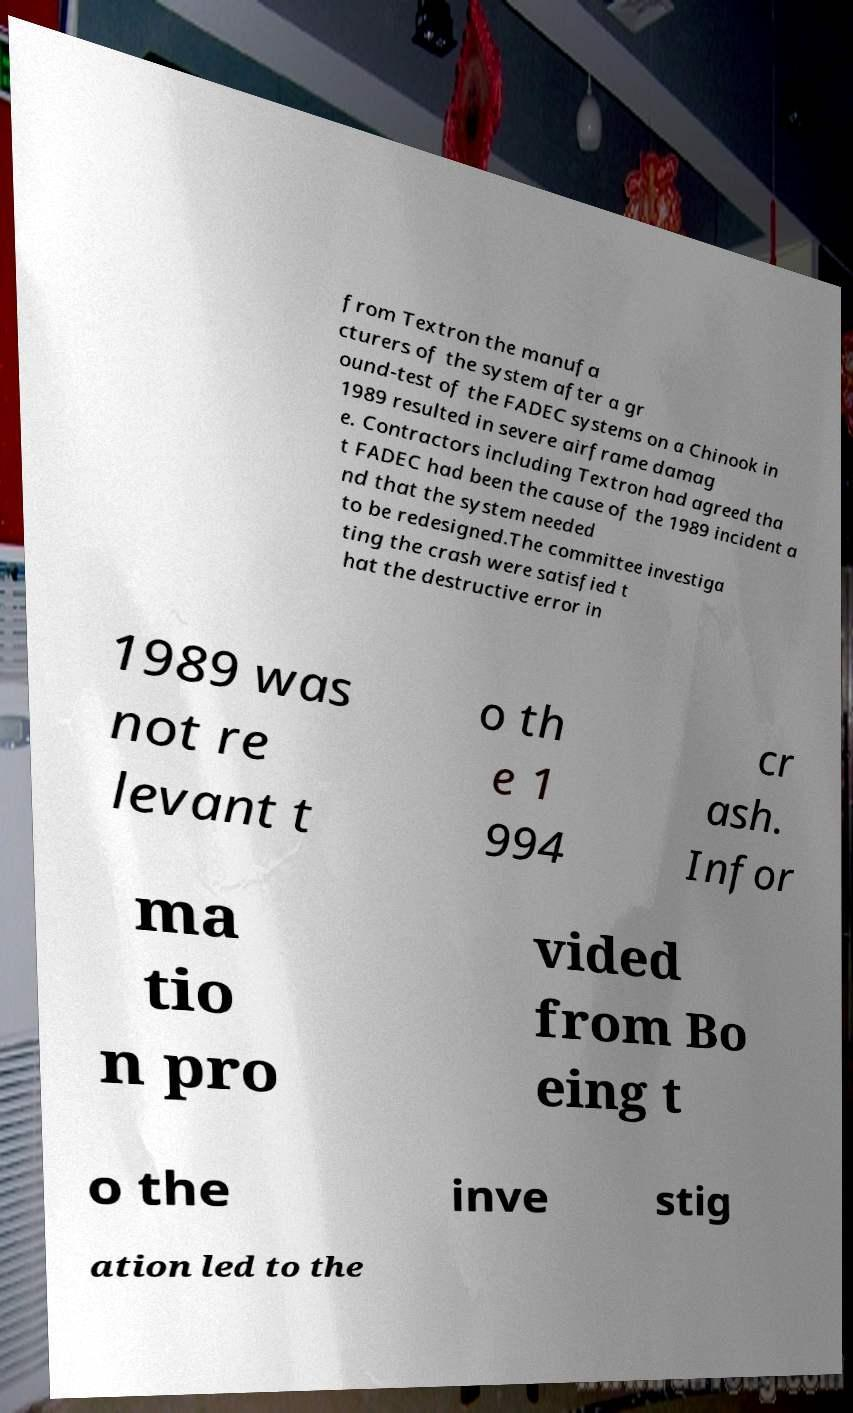There's text embedded in this image that I need extracted. Can you transcribe it verbatim? from Textron the manufa cturers of the system after a gr ound-test of the FADEC systems on a Chinook in 1989 resulted in severe airframe damag e. Contractors including Textron had agreed tha t FADEC had been the cause of the 1989 incident a nd that the system needed to be redesigned.The committee investiga ting the crash were satisfied t hat the destructive error in 1989 was not re levant t o th e 1 994 cr ash. Infor ma tio n pro vided from Bo eing t o the inve stig ation led to the 